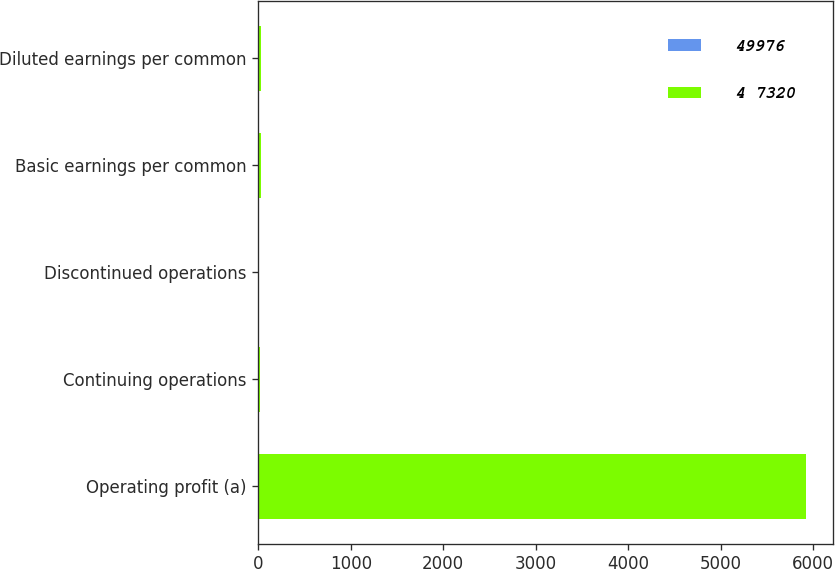Convert chart. <chart><loc_0><loc_0><loc_500><loc_500><stacked_bar_chart><ecel><fcel>Operating profit (a)<fcel>Continuing operations<fcel>Discontinued operations<fcel>Basic earnings per common<fcel>Diluted earnings per common<nl><fcel>49976<fcel>6.89<fcel>6.63<fcel>0.26<fcel>6.89<fcel>6.82<nl><fcel>4 7320<fcel>5910<fcel>12.28<fcel>5.05<fcel>17.33<fcel>17.12<nl></chart> 